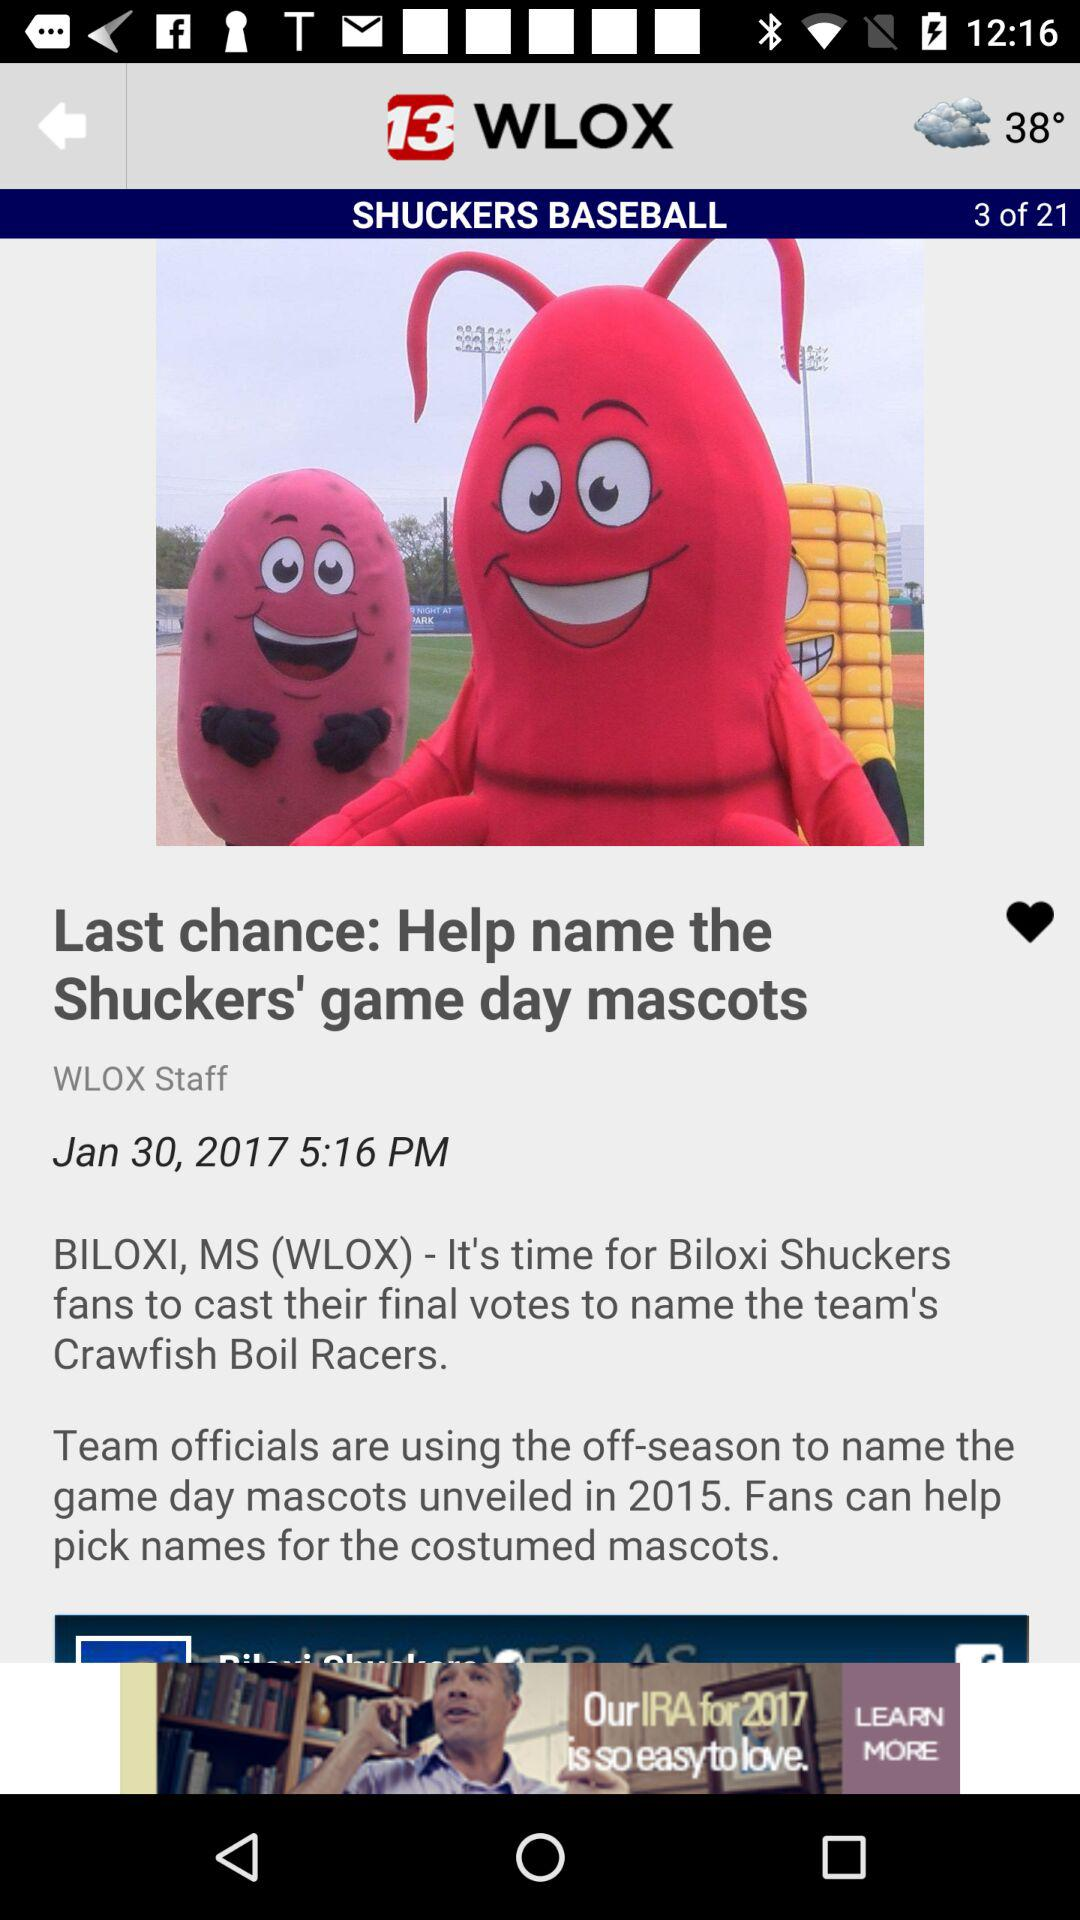What is the mentioned date? The mentioned date is January 30, 2017. 